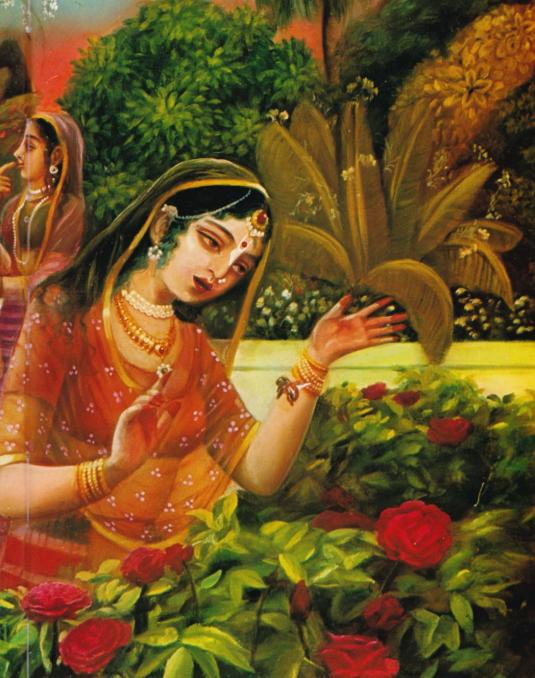Describe a day in the life of the primary woman if she lived in the era depicted by this painting. A day in the life of the primary woman might begin with early morning prayers and rituals, followed by tending to her family and household duties. She would participate in various cultural and social activities, such as preparing meals, engaging in traditional arts like music or painting, and spending time in the garden appreciating nature's beauty. Her attire and jewelry indicate her high societal status, so interactions with other noblewomen and participation in courtly events could be common. In the evening, she might listen to or narrate stories from epics and spend peaceful moments amidst the serene garden, reflecting on the day's happenings. 